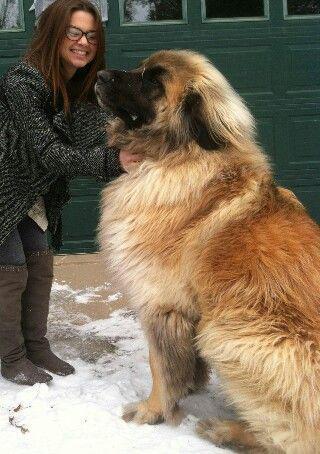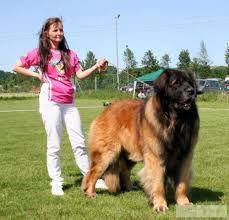The first image is the image on the left, the second image is the image on the right. Evaluate the accuracy of this statement regarding the images: "In one image, a woman in glasses is on the left of a dog that is sitting up, and the other image includes a dog standing in profile on grass.". Is it true? Answer yes or no. Yes. The first image is the image on the left, the second image is the image on the right. Considering the images on both sides, is "There is a large body of water in the background of at least one of the pictures." valid? Answer yes or no. No. 